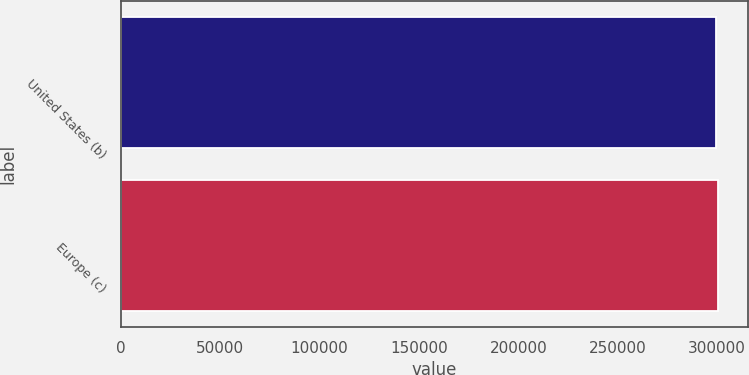Convert chart. <chart><loc_0><loc_0><loc_500><loc_500><bar_chart><fcel>United States (b)<fcel>Europe (c)<nl><fcel>299384<fcel>300415<nl></chart> 